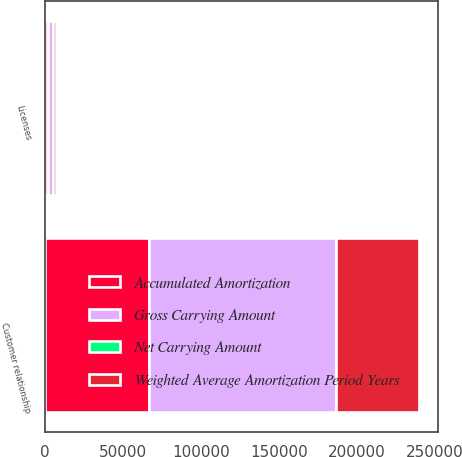<chart> <loc_0><loc_0><loc_500><loc_500><stacked_bar_chart><ecel><fcel>Customer relationship<fcel>Licenses<nl><fcel>Gross Carrying Amount<fcel>120000<fcel>3368<nl><fcel>Accumulated Amortization<fcel>66866<fcel>1601<nl><fcel>Weighted Average Amortization Period Years<fcel>53134<fcel>1767<nl><fcel>Net Carrying Amount<fcel>6<fcel>5.6<nl></chart> 